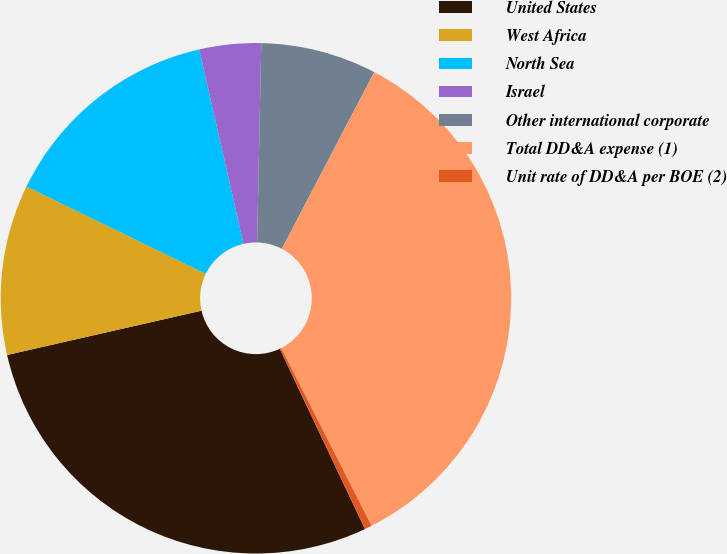<chart> <loc_0><loc_0><loc_500><loc_500><pie_chart><fcel>United States<fcel>West Africa<fcel>North Sea<fcel>Israel<fcel>Other international corporate<fcel>Total DD&A expense (1)<fcel>Unit rate of DD&A per BOE (2)<nl><fcel>28.46%<fcel>10.78%<fcel>14.22%<fcel>3.9%<fcel>7.34%<fcel>34.85%<fcel>0.46%<nl></chart> 